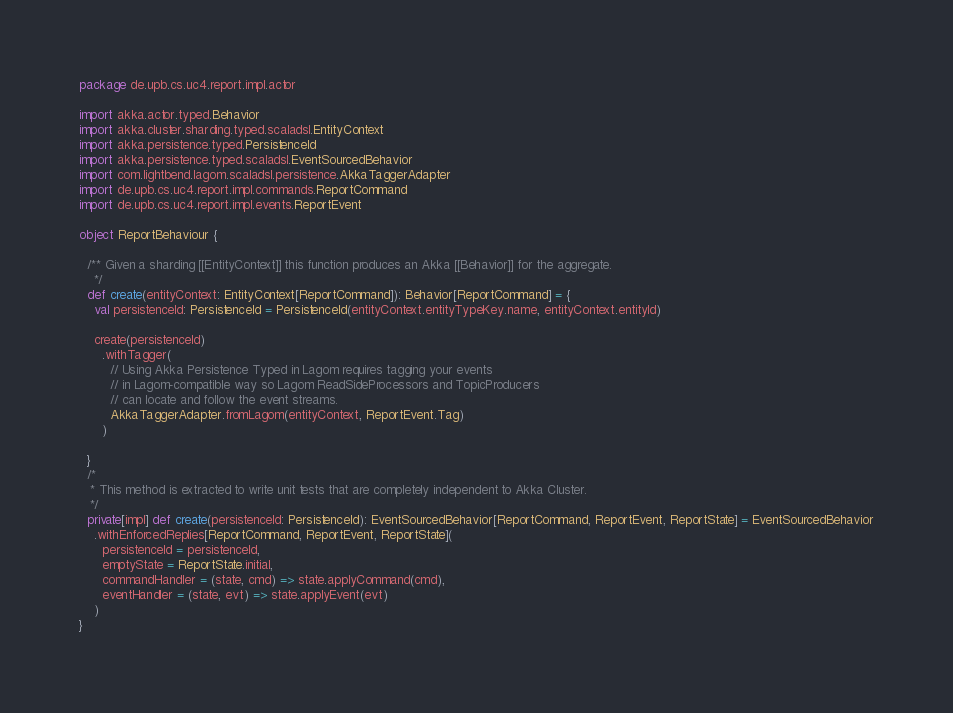<code> <loc_0><loc_0><loc_500><loc_500><_Scala_>package de.upb.cs.uc4.report.impl.actor

import akka.actor.typed.Behavior
import akka.cluster.sharding.typed.scaladsl.EntityContext
import akka.persistence.typed.PersistenceId
import akka.persistence.typed.scaladsl.EventSourcedBehavior
import com.lightbend.lagom.scaladsl.persistence.AkkaTaggerAdapter
import de.upb.cs.uc4.report.impl.commands.ReportCommand
import de.upb.cs.uc4.report.impl.events.ReportEvent

object ReportBehaviour {

  /** Given a sharding [[EntityContext]] this function produces an Akka [[Behavior]] for the aggregate.
    */
  def create(entityContext: EntityContext[ReportCommand]): Behavior[ReportCommand] = {
    val persistenceId: PersistenceId = PersistenceId(entityContext.entityTypeKey.name, entityContext.entityId)

    create(persistenceId)
      .withTagger(
        // Using Akka Persistence Typed in Lagom requires tagging your events
        // in Lagom-compatible way so Lagom ReadSideProcessors and TopicProducers
        // can locate and follow the event streams.
        AkkaTaggerAdapter.fromLagom(entityContext, ReportEvent.Tag)
      )

  }
  /*
   * This method is extracted to write unit tests that are completely independent to Akka Cluster.
   */
  private[impl] def create(persistenceId: PersistenceId): EventSourcedBehavior[ReportCommand, ReportEvent, ReportState] = EventSourcedBehavior
    .withEnforcedReplies[ReportCommand, ReportEvent, ReportState](
      persistenceId = persistenceId,
      emptyState = ReportState.initial,
      commandHandler = (state, cmd) => state.applyCommand(cmd),
      eventHandler = (state, evt) => state.applyEvent(evt)
    )
}
</code> 